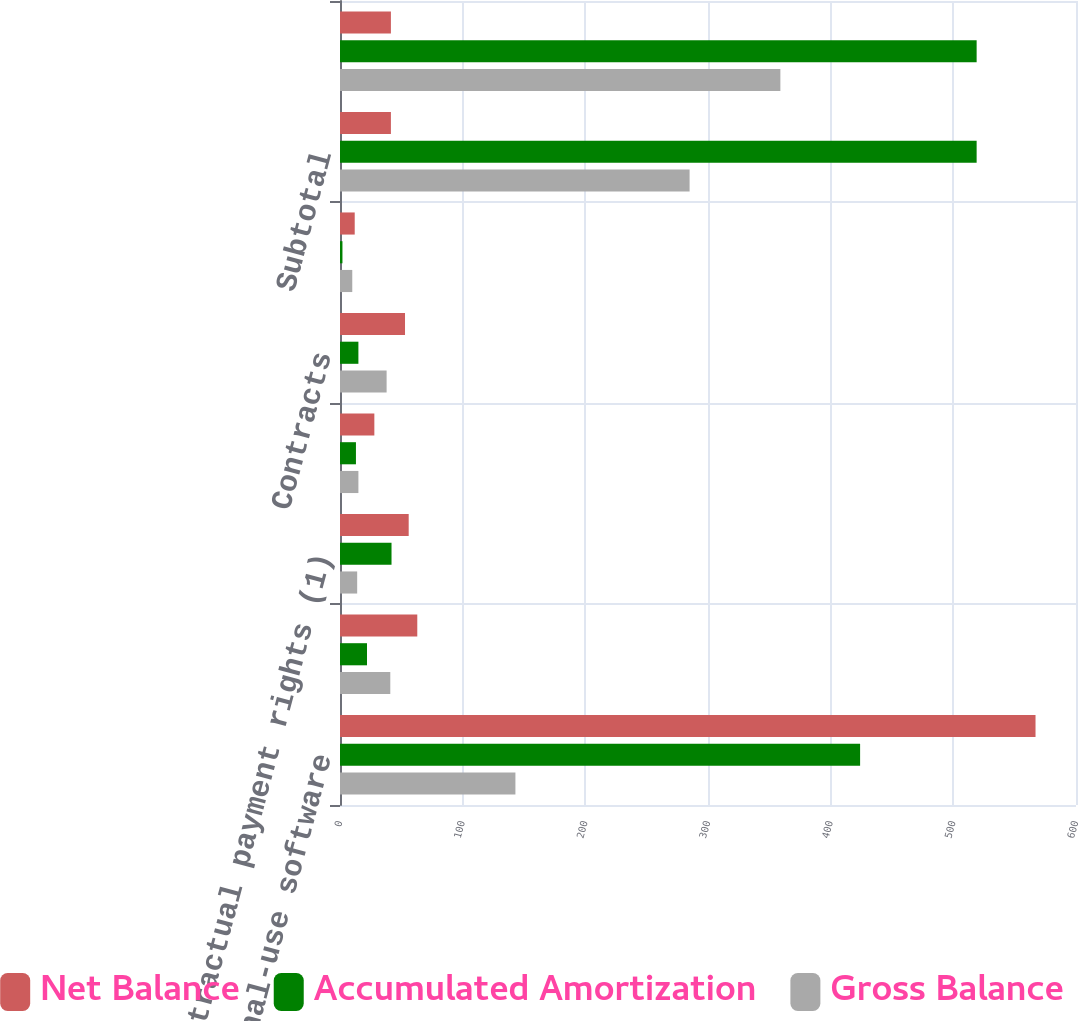Convert chart to OTSL. <chart><loc_0><loc_0><loc_500><loc_500><stacked_bar_chart><ecel><fcel>Internal-use software<fcel>Sales concessions<fcel>Contractual payment rights (1)<fcel>Management rights<fcel>Contracts<fcel>Other (2)<fcel>Subtotal<fcel>Total<nl><fcel>Net Balance<fcel>567<fcel>63<fcel>56<fcel>28<fcel>53<fcel>12<fcel>41.5<fcel>41.5<nl><fcel>Accumulated Amortization<fcel>424<fcel>22<fcel>42<fcel>13<fcel>15<fcel>2<fcel>519<fcel>519<nl><fcel>Gross Balance<fcel>143<fcel>41<fcel>14<fcel>15<fcel>38<fcel>10<fcel>285<fcel>359<nl></chart> 